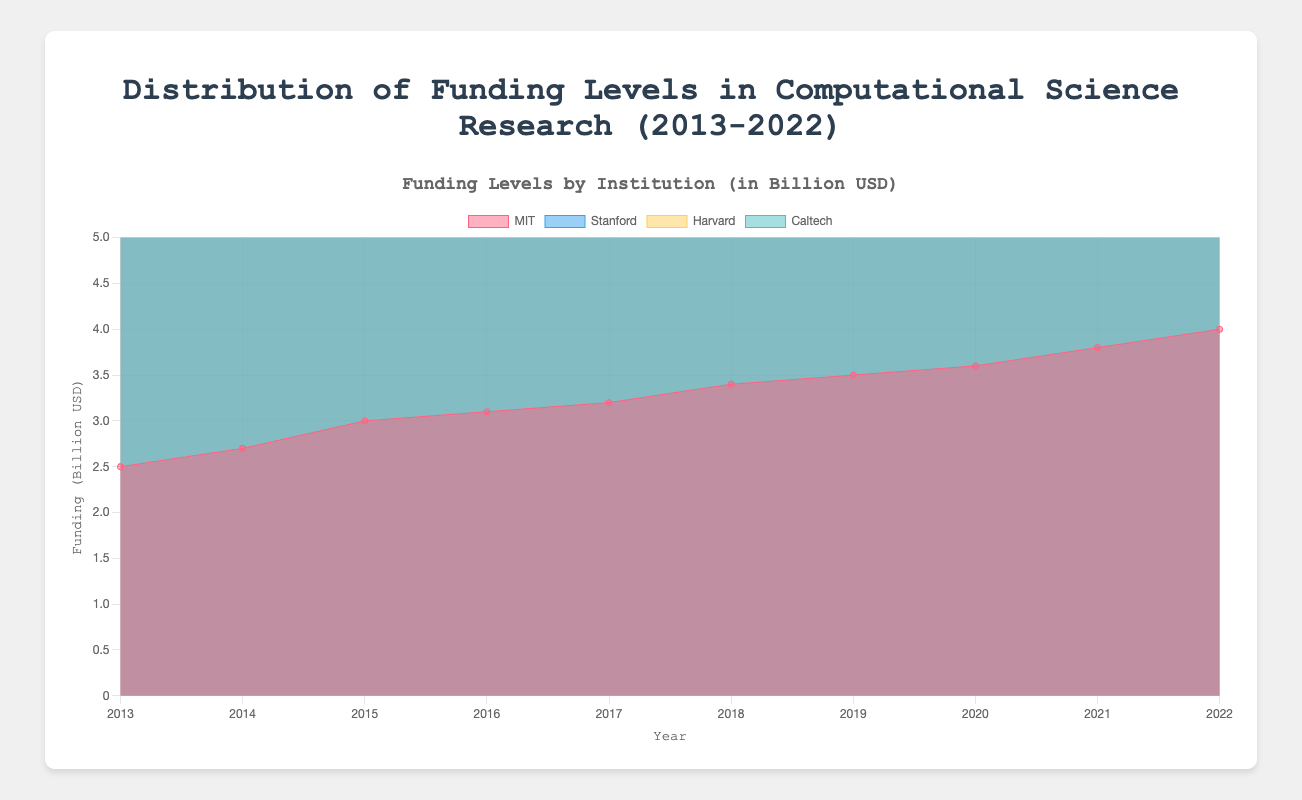What is the title of the chart? The title of the chart is prominently displayed at the top center of the figure.
Answer: Distribution of Funding Levels in Computational Science Research (2013-2022) What are the years covered in the chart? The x-axis of the chart shows years from 2013 to 2022.
Answer: 2013-2022 Which institution had the highest funding in 2022? The data color-coded by institution shows that Stanford had the highest funding in 2022.
Answer: Stanford How did the funding for Harvard change from 2013 to 2022? The line representing Harvard starts at $2.0 billion in 2013 and rises to $3.9 billion in 2022, showing a consistent increase.
Answer: Increased from $2.0 billion to $3.9 billion Compare the funding trends between MIT and Caltech over the decade. While both institutions showed an increase in funding over the decade, MIT had a sharper increase starting from $2.5 billion to $4.0 billion, whereas Caltech's funding increased from $2.2 billion to $3.4 billion.
Answer: MIT had a sharper increase compared to Caltech In which year did Stanford first surpass $4 billion in funding? Observing Stanford's funding line, it first surpasses $4 billion in the year 2019.
Answer: 2019 What is the total funding for all institutions in 2020? Adding the 2020 values for all institutions: MIT ($3.6B) + Stanford ($4.2B) + Harvard ($3.5B) + Caltech ($3.1B) = $14.4B.
Answer: $14.4 billion Between which years did MIT see the greatest increase in funding? The funding for MIT increased notably between 2021 and 2022 from $3.8 billion to $4.0 billion, which is a $0.2 billion increase.
Answer: 2021-2022 Which institution had the steadiest growth over the decade? By examining the slopes of the funding curves, Harvard shows a steady and consistent increase each year without any large jumps or declines.
Answer: Harvard 